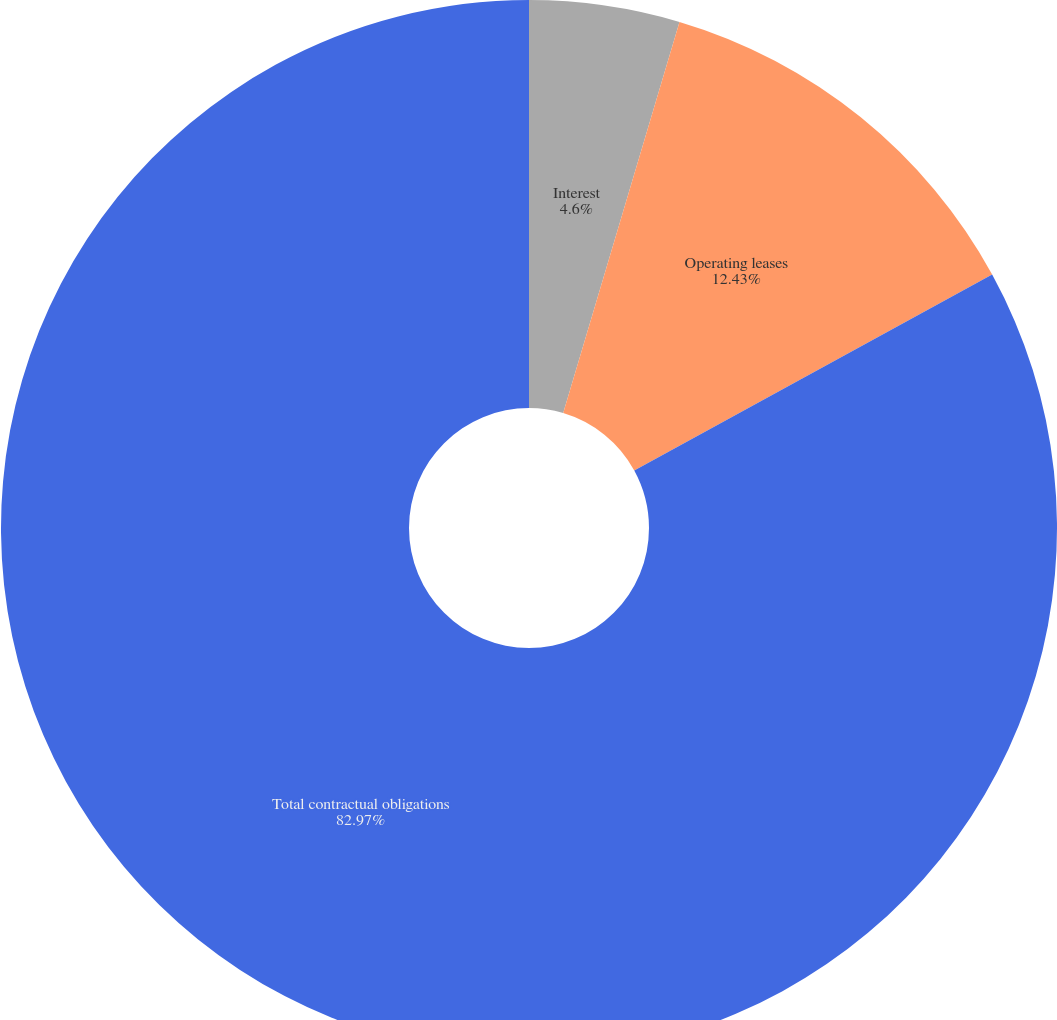<chart> <loc_0><loc_0><loc_500><loc_500><pie_chart><fcel>Interest<fcel>Operating leases<fcel>Total contractual obligations<nl><fcel>4.6%<fcel>12.43%<fcel>82.97%<nl></chart> 